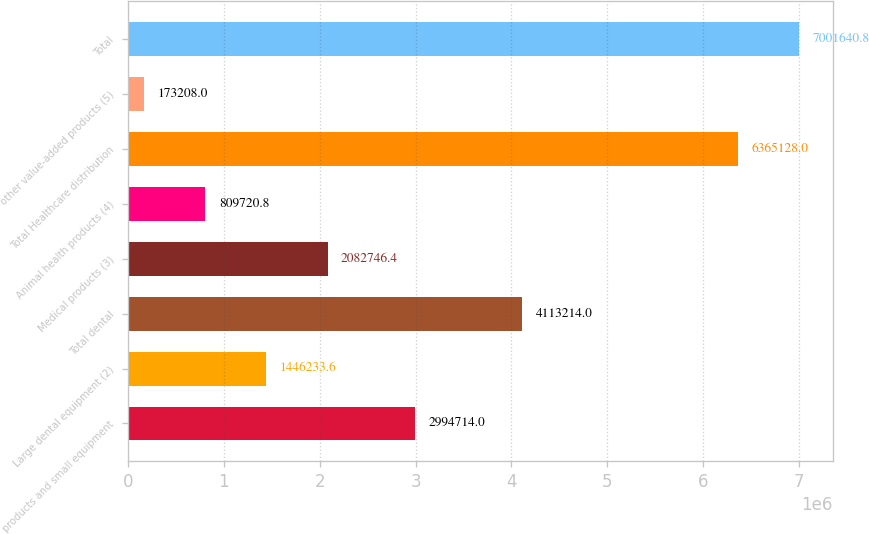<chart> <loc_0><loc_0><loc_500><loc_500><bar_chart><fcel>products and small equipment<fcel>Large dental equipment (2)<fcel>Total dental<fcel>Medical products (3)<fcel>Animal health products (4)<fcel>Total Healthcare distribution<fcel>other value-added products (5)<fcel>Total<nl><fcel>2.99471e+06<fcel>1.44623e+06<fcel>4.11321e+06<fcel>2.08275e+06<fcel>809721<fcel>6.36513e+06<fcel>173208<fcel>7.00164e+06<nl></chart> 